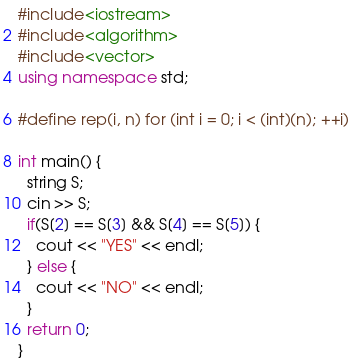<code> <loc_0><loc_0><loc_500><loc_500><_C++_>#include<iostream>
#include<algorithm>
#include<vector>
using namespace std;

#define rep(i, n) for (int i = 0; i < (int)(n); ++i)

int main() {
  string S;
  cin >> S;
  if(S[2] == S[3] && S[4] == S[5]) {
    cout << "YES" << endl;
  } else {
    cout << "NO" << endl;
  }
  return 0;
}</code> 